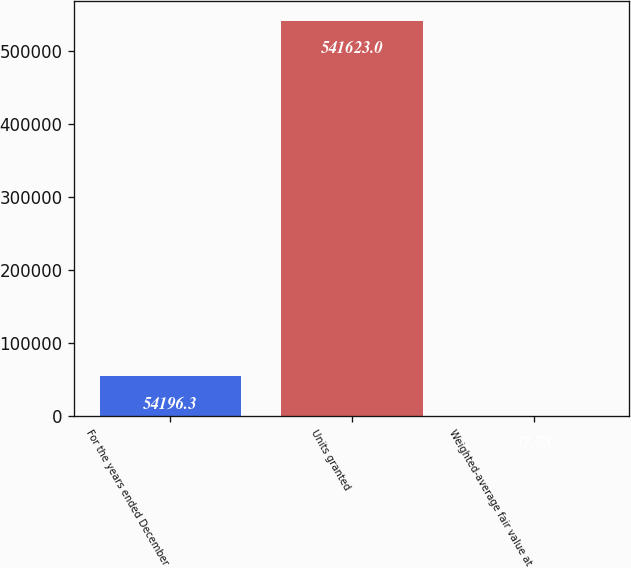Convert chart to OTSL. <chart><loc_0><loc_0><loc_500><loc_500><bar_chart><fcel>For the years ended December<fcel>Units granted<fcel>Weighted-average fair value at<nl><fcel>54196.3<fcel>541623<fcel>37.78<nl></chart> 